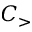Convert formula to latex. <formula><loc_0><loc_0><loc_500><loc_500>C _ { > }</formula> 